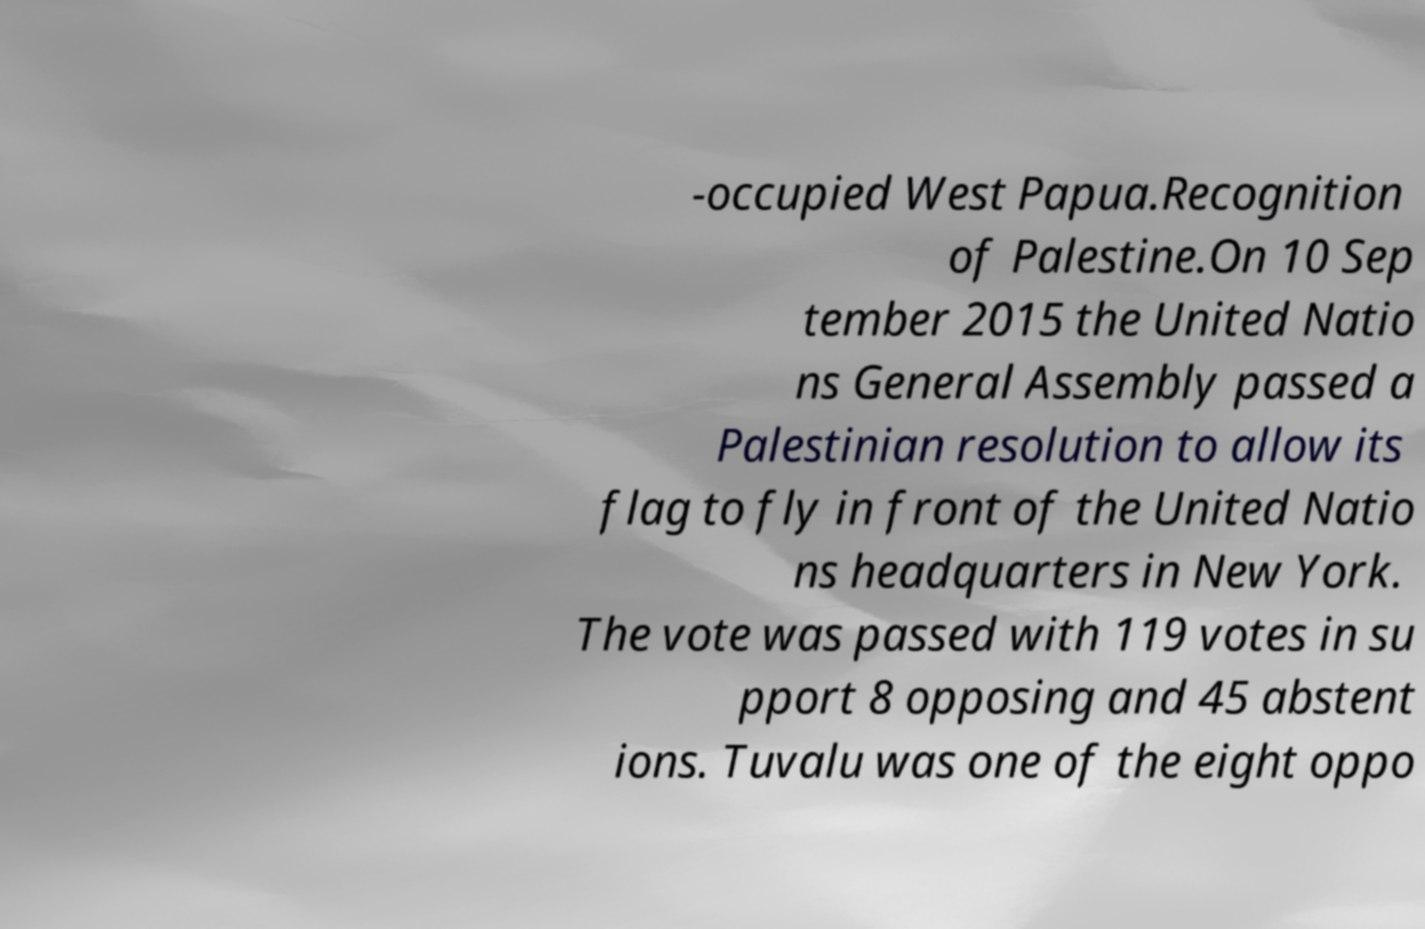Please read and relay the text visible in this image. What does it say? -occupied West Papua.Recognition of Palestine.On 10 Sep tember 2015 the United Natio ns General Assembly passed a Palestinian resolution to allow its flag to fly in front of the United Natio ns headquarters in New York. The vote was passed with 119 votes in su pport 8 opposing and 45 abstent ions. Tuvalu was one of the eight oppo 